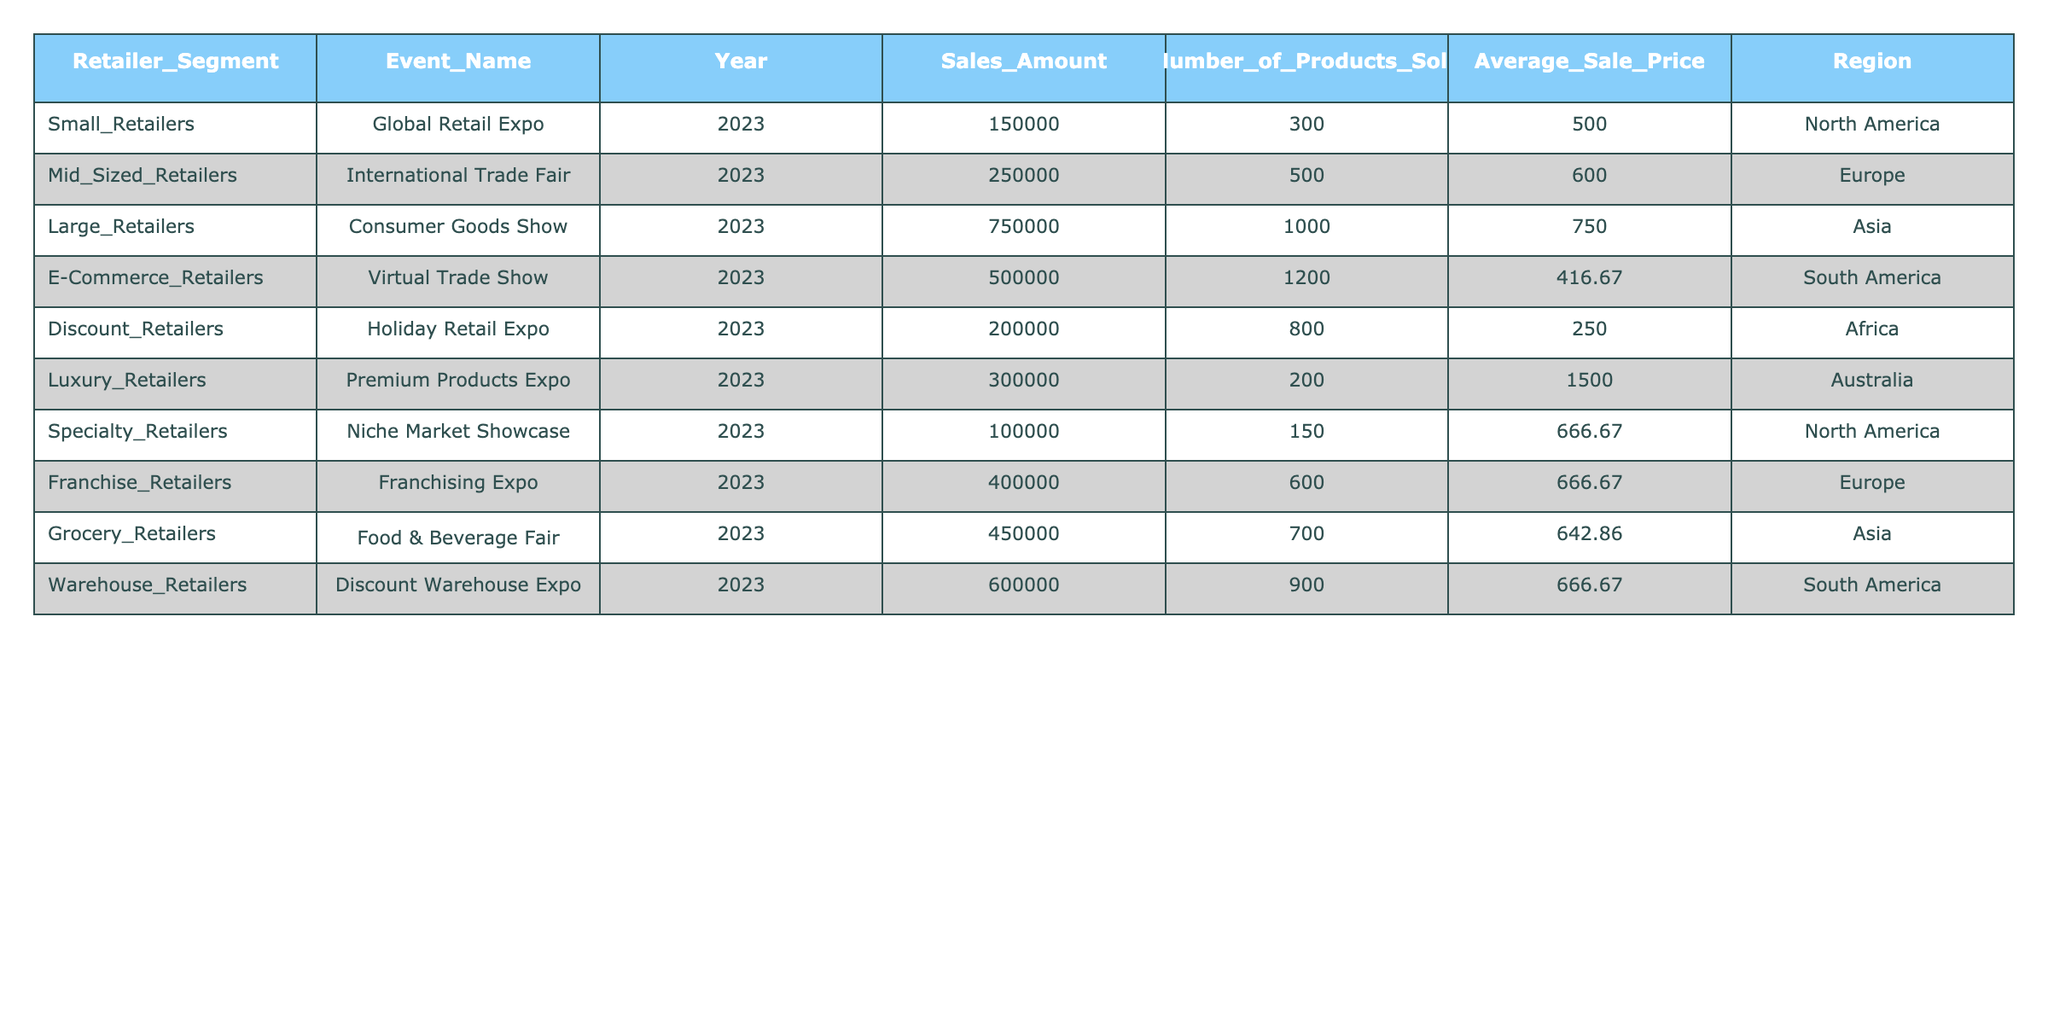What is the total sales amount of Large Retailers during the Consumer Goods Show? The sales amount for Large Retailers at the Consumer Goods Show in 2023 is listed in the table as 750,000.00.
Answer: 750000.00 What is the Average Sale Price for E-Commerce Retailers at the Virtual Trade Show? The Average Sale Price for E-Commerce Retailers as per the table is listed as 416.67.
Answer: 416.67 Which retailer segment generated the highest sales amount during the trade show events? By examining the sales amounts for each segment, Large Retailers with sales of 750,000.00 at the Consumer Goods Show has the highest value compared to others.
Answer: Large Retailers What is the combined sales amount of Small and Specialty Retailers? The sales amount for Small Retailers is 150,000.00 and for Specialty Retailers is 100,000.00. Adding these gives 150,000.00 + 100,000.00 = 250,000.00.
Answer: 250000.00 Are Discount Retailers making more than Grocery Retailers in sales? Discount Retailers have sales of 200,000.00 while Grocery Retailers have sales of 450,000.00. Since 200,000.00 is less than 450,000.00, Discount Retailers are not making more.
Answer: No Which region had the highest sales for Franchise Retailers and what was the amount? Franchise Retailers' sales amounted to 400,000.00, and they are in the Europe region. This is the only value for this segment, so it's also the highest.
Answer: Europe, 400000.00 What is the average sales amount of all retailer segments listed in the table? The total sales amount is 150,000.00 + 250,000.00 + 750,000.00 + 500,000.00 + 200,000.00 + 300,000.00 + 100,000.00 + 400,000.00 + 450,000.00 + 600,000.00 = 3,800,000.00. There are 10 retailer segments, so the average is 3,800,000.00 / 10 = 380,000.00.
Answer: 380000.00 Which retailer segment and event had the lowest number of products sold? By examining the number of products sold for each segment, Specialty Retailers sold the least at 150 during the Niche Market Showcase.
Answer: Specialty Retailers, Niche Market Showcase Is there a segment with an Average Sale Price higher than 1,000? The Luxury Retailers have an Average Sale Price of 1500.00, which is indeed higher than 1,000.00.
Answer: Yes What is the difference in sales amounts between Warehouse Retailers and Mid-Sized Retailers? The sales amount for Warehouse Retailers is 600,000.00 and for Mid-Sized Retailers is 250,000.00. The difference is 600,000.00 - 250,000.00 = 350,000.00.
Answer: 350000.00 Which retailer segment has the highest average sale price and how much is it? Luxury Retailers have the highest Average Sale Price of 1500.00, higher than all other segments listed in the table.
Answer: Luxury Retailers, 1500.00 